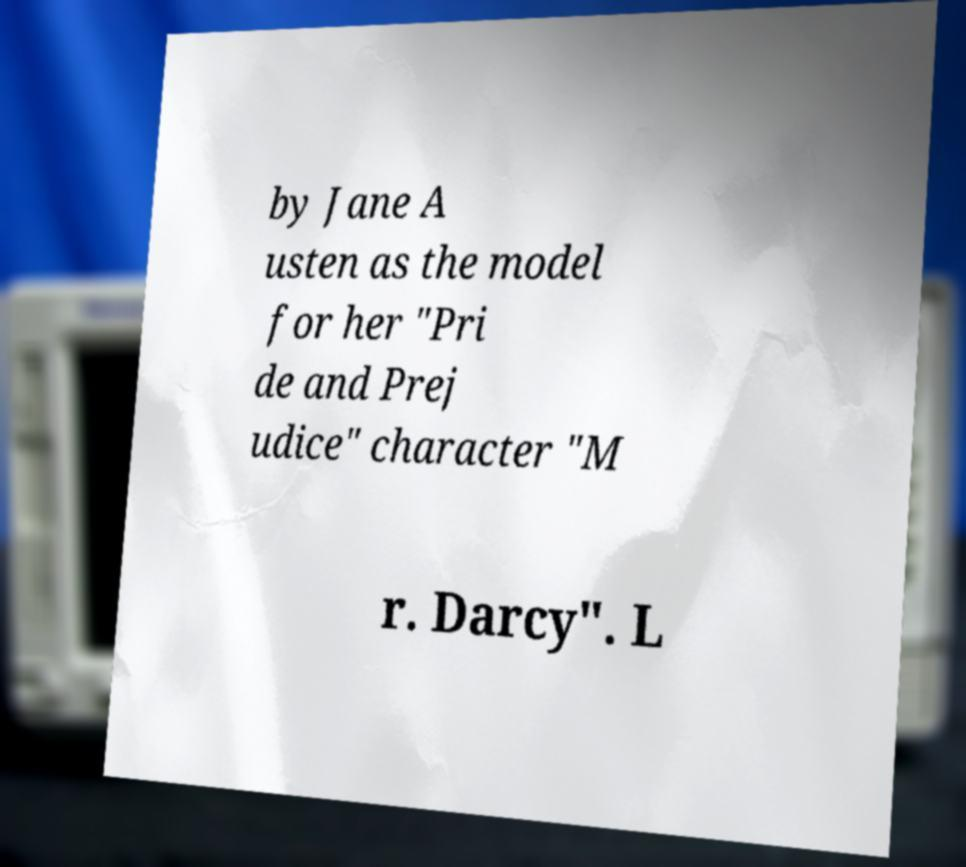Can you accurately transcribe the text from the provided image for me? by Jane A usten as the model for her "Pri de and Prej udice" character "M r. Darcy". L 